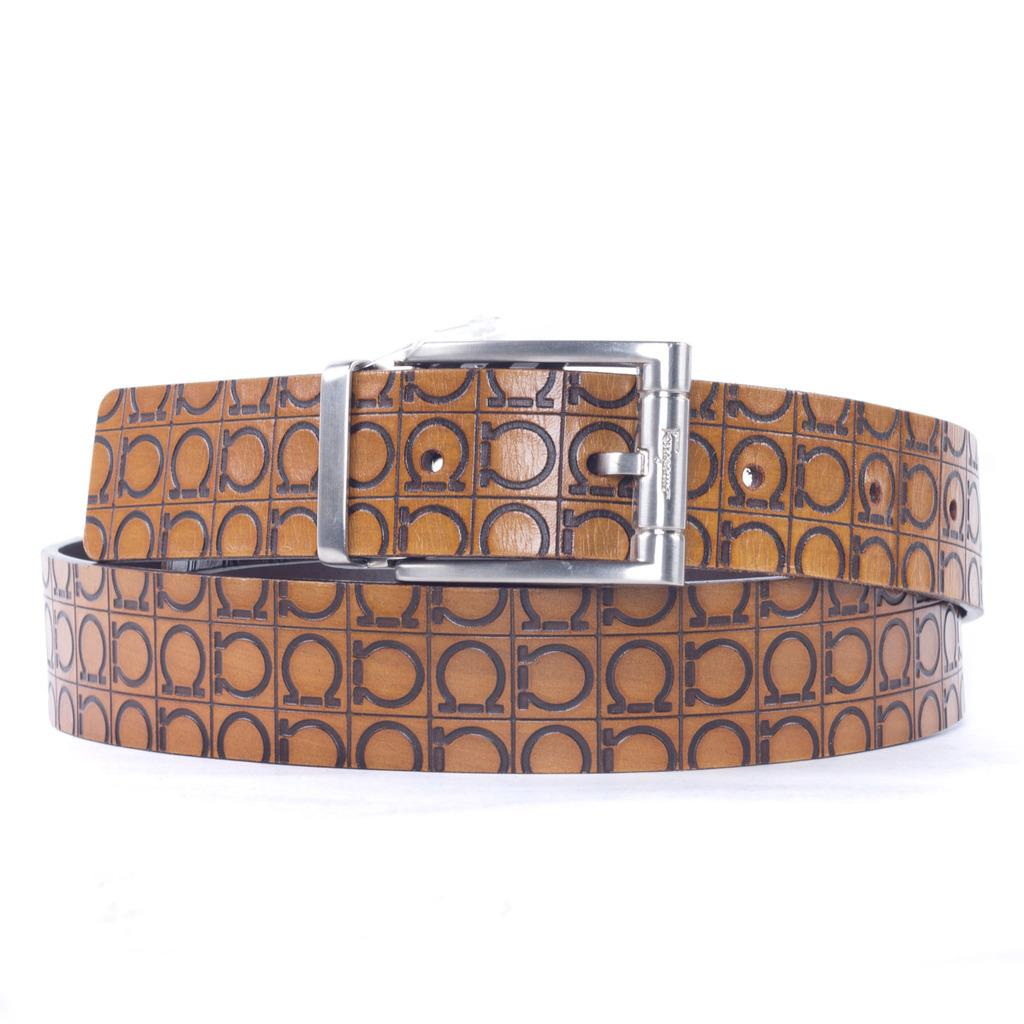What is the main object in the center of the image? There is a belt in the center of the image. What features does the belt have? The belt has a loop, a buckle, and a strap. What color is the background of the image? The background of the image is white in color. How many people are in the crowd surrounding the belt in the image? There is no crowd present in the image; it only features the belt with its features. 